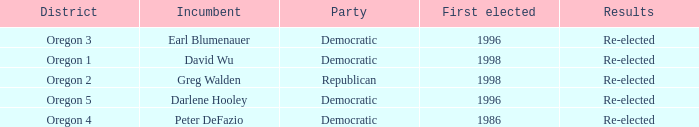Who is the incumbent for the Oregon 5 District that was elected in 1996? Darlene Hooley. 